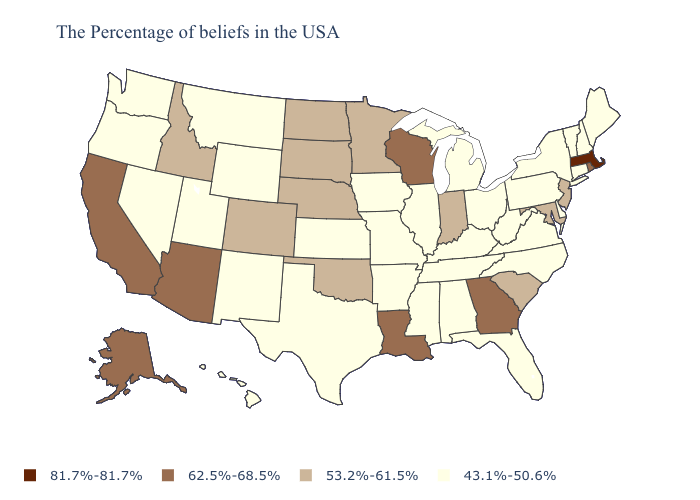What is the highest value in states that border Iowa?
Be succinct. 62.5%-68.5%. Does the first symbol in the legend represent the smallest category?
Give a very brief answer. No. What is the highest value in the West ?
Give a very brief answer. 62.5%-68.5%. Does the first symbol in the legend represent the smallest category?
Concise answer only. No. What is the value of South Carolina?
Give a very brief answer. 53.2%-61.5%. Which states hav the highest value in the West?
Concise answer only. Arizona, California, Alaska. Does Maryland have a higher value than Idaho?
Give a very brief answer. No. Among the states that border New Jersey , which have the lowest value?
Quick response, please. New York, Delaware, Pennsylvania. What is the lowest value in the West?
Quick response, please. 43.1%-50.6%. Name the states that have a value in the range 81.7%-81.7%?
Be succinct. Massachusetts. Among the states that border Idaho , which have the highest value?
Concise answer only. Wyoming, Utah, Montana, Nevada, Washington, Oregon. Name the states that have a value in the range 81.7%-81.7%?
Write a very short answer. Massachusetts. Name the states that have a value in the range 53.2%-61.5%?
Short answer required. New Jersey, Maryland, South Carolina, Indiana, Minnesota, Nebraska, Oklahoma, South Dakota, North Dakota, Colorado, Idaho. What is the value of Massachusetts?
Quick response, please. 81.7%-81.7%. Name the states that have a value in the range 43.1%-50.6%?
Keep it brief. Maine, New Hampshire, Vermont, Connecticut, New York, Delaware, Pennsylvania, Virginia, North Carolina, West Virginia, Ohio, Florida, Michigan, Kentucky, Alabama, Tennessee, Illinois, Mississippi, Missouri, Arkansas, Iowa, Kansas, Texas, Wyoming, New Mexico, Utah, Montana, Nevada, Washington, Oregon, Hawaii. 